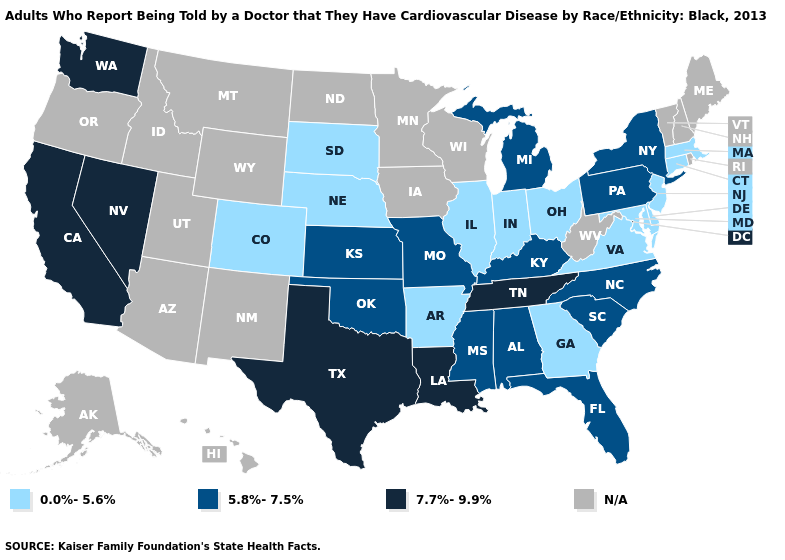What is the lowest value in the Northeast?
Short answer required. 0.0%-5.6%. Name the states that have a value in the range 7.7%-9.9%?
Be succinct. California, Louisiana, Nevada, Tennessee, Texas, Washington. What is the value of Connecticut?
Be succinct. 0.0%-5.6%. Is the legend a continuous bar?
Concise answer only. No. What is the value of Nevada?
Give a very brief answer. 7.7%-9.9%. What is the highest value in the USA?
Give a very brief answer. 7.7%-9.9%. Is the legend a continuous bar?
Short answer required. No. Name the states that have a value in the range N/A?
Be succinct. Alaska, Arizona, Hawaii, Idaho, Iowa, Maine, Minnesota, Montana, New Hampshire, New Mexico, North Dakota, Oregon, Rhode Island, Utah, Vermont, West Virginia, Wisconsin, Wyoming. Which states have the lowest value in the USA?
Write a very short answer. Arkansas, Colorado, Connecticut, Delaware, Georgia, Illinois, Indiana, Maryland, Massachusetts, Nebraska, New Jersey, Ohio, South Dakota, Virginia. Does the first symbol in the legend represent the smallest category?
Concise answer only. Yes. Name the states that have a value in the range N/A?
Keep it brief. Alaska, Arizona, Hawaii, Idaho, Iowa, Maine, Minnesota, Montana, New Hampshire, New Mexico, North Dakota, Oregon, Rhode Island, Utah, Vermont, West Virginia, Wisconsin, Wyoming. Name the states that have a value in the range N/A?
Answer briefly. Alaska, Arizona, Hawaii, Idaho, Iowa, Maine, Minnesota, Montana, New Hampshire, New Mexico, North Dakota, Oregon, Rhode Island, Utah, Vermont, West Virginia, Wisconsin, Wyoming. Name the states that have a value in the range 5.8%-7.5%?
Give a very brief answer. Alabama, Florida, Kansas, Kentucky, Michigan, Mississippi, Missouri, New York, North Carolina, Oklahoma, Pennsylvania, South Carolina. Name the states that have a value in the range 5.8%-7.5%?
Short answer required. Alabama, Florida, Kansas, Kentucky, Michigan, Mississippi, Missouri, New York, North Carolina, Oklahoma, Pennsylvania, South Carolina. What is the value of Colorado?
Quick response, please. 0.0%-5.6%. 